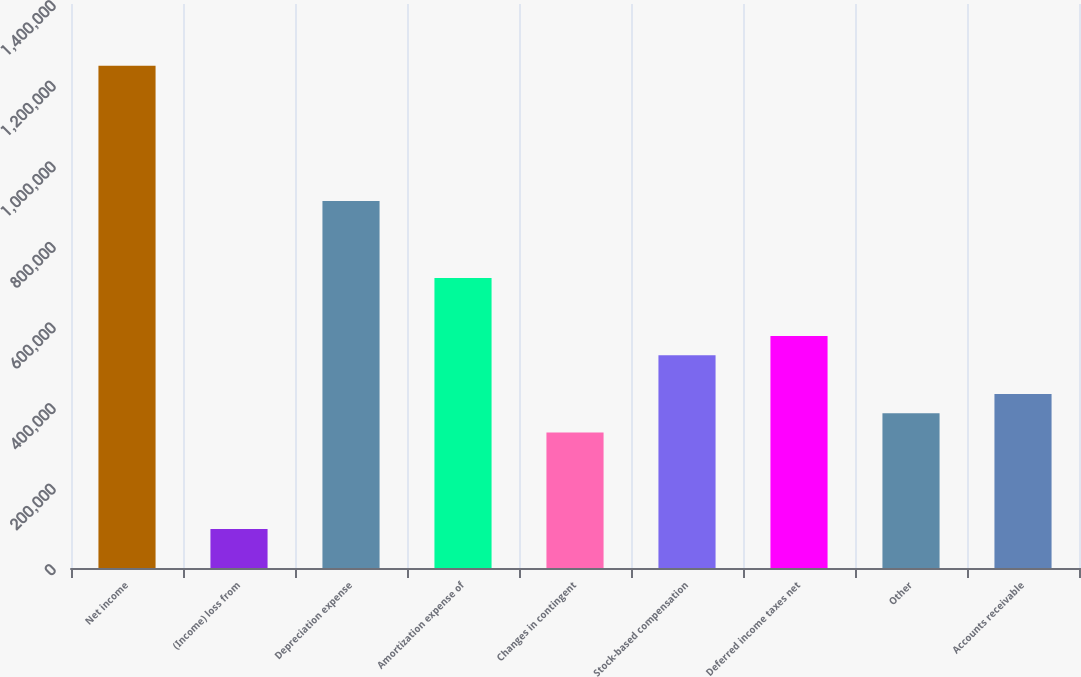Convert chart. <chart><loc_0><loc_0><loc_500><loc_500><bar_chart><fcel>Net income<fcel>(Income) loss from<fcel>Depreciation expense<fcel>Amortization expense of<fcel>Changes in contingent<fcel>Stock-based compensation<fcel>Deferred income taxes net<fcel>Other<fcel>Accounts receivable<nl><fcel>1.24651e+06<fcel>96895.6<fcel>911209<fcel>719606<fcel>336400<fcel>528003<fcel>575904<fcel>384300<fcel>432201<nl></chart> 